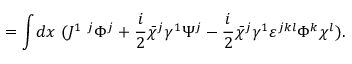<formula> <loc_0><loc_0><loc_500><loc_500>= \int \, d x ( J ^ { 1 j } \Phi ^ { j } + { \frac { i } { 2 } } \bar { \chi } ^ { j } \gamma ^ { 1 } \Psi ^ { j } - { \frac { i } { 2 } } \bar { \chi } ^ { j } \gamma ^ { 1 } \varepsilon ^ { j k l } \Phi ^ { k } \chi ^ { l } ) .</formula> 